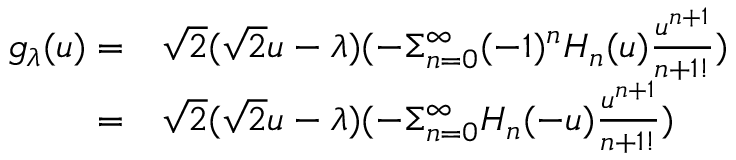Convert formula to latex. <formula><loc_0><loc_0><loc_500><loc_500>\begin{array} { r l } { g _ { \lambda } ( u ) = } & \sqrt { 2 } ( \sqrt { 2 } u - \lambda ) ( - \Sigma _ { n = 0 } ^ { \infty } ( - 1 ) ^ { n } H _ { n } ( u ) \frac { u ^ { n + 1 } } { { n + 1 } ! } ) } \\ { = } & \sqrt { 2 } ( \sqrt { 2 } u - \lambda ) ( - \Sigma _ { n = 0 } ^ { \infty } H _ { n } ( - u ) \frac { u ^ { n + 1 } } { { n + 1 } ! } ) } \end{array}</formula> 